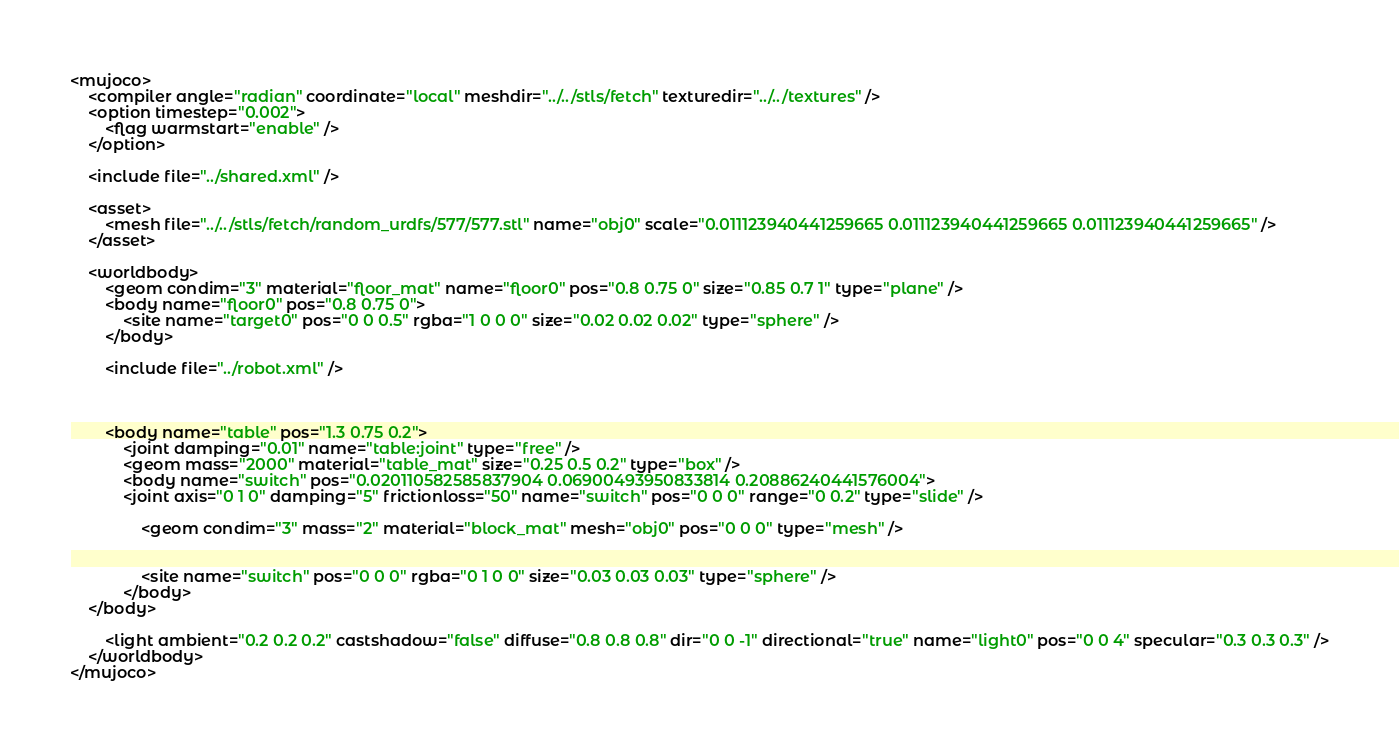Convert code to text. <code><loc_0><loc_0><loc_500><loc_500><_XML_><mujoco>
	<compiler angle="radian" coordinate="local" meshdir="../../stls/fetch" texturedir="../../textures" />
	<option timestep="0.002">
		<flag warmstart="enable" />
	</option>

	<include file="../shared.xml" />

	<asset>
		<mesh file="../../stls/fetch/random_urdfs/577/577.stl" name="obj0" scale="0.011123940441259665 0.011123940441259665 0.011123940441259665" />
	</asset>

	<worldbody>
		<geom condim="3" material="floor_mat" name="floor0" pos="0.8 0.75 0" size="0.85 0.7 1" type="plane" />
		<body name="floor0" pos="0.8 0.75 0">
			<site name="target0" pos="0 0 0.5" rgba="1 0 0 0" size="0.02 0.02 0.02" type="sphere" />
		</body>

		<include file="../robot.xml" />

		

		<body name="table" pos="1.3 0.75 0.2">
			<joint damping="0.01" name="table:joint" type="free" />
			<geom mass="2000" material="table_mat" size="0.25 0.5 0.2" type="box" />
			<body name="switch" pos="0.020110582585837904 0.06900493950833814 0.20886240441576004">
		    <joint axis="0 1 0" damping="5" frictionloss="50" name="switch" pos="0 0 0" range="0 0.2" type="slide" />
				
				<geom condim="3" mass="2" material="block_mat" mesh="obj0" pos="0 0 0" type="mesh" />
				
				
				<site name="switch" pos="0 0 0" rgba="0 1 0 0" size="0.03 0.03 0.03" type="sphere" />
			</body>
    </body>

		<light ambient="0.2 0.2 0.2" castshadow="false" diffuse="0.8 0.8 0.8" dir="0 0 -1" directional="true" name="light0" pos="0 0 4" specular="0.3 0.3 0.3" />
	</worldbody>
</mujoco></code> 